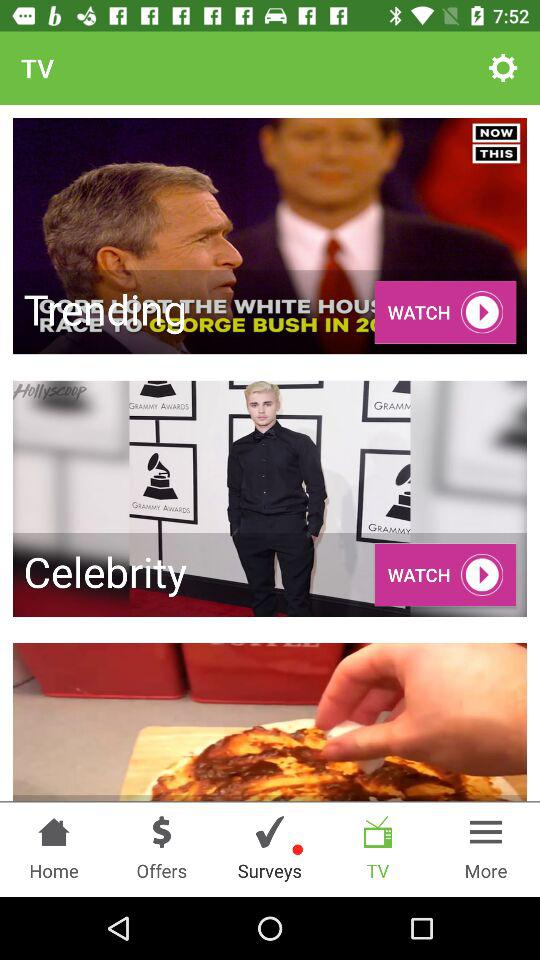How many videos are being displayed on the screen?
Answer the question using a single word or phrase. 3 